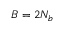Convert formula to latex. <formula><loc_0><loc_0><loc_500><loc_500>B = 2 N _ { b }</formula> 